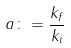<formula> <loc_0><loc_0><loc_500><loc_500>a \colon = \frac { k _ { f } } { k _ { i } }</formula> 